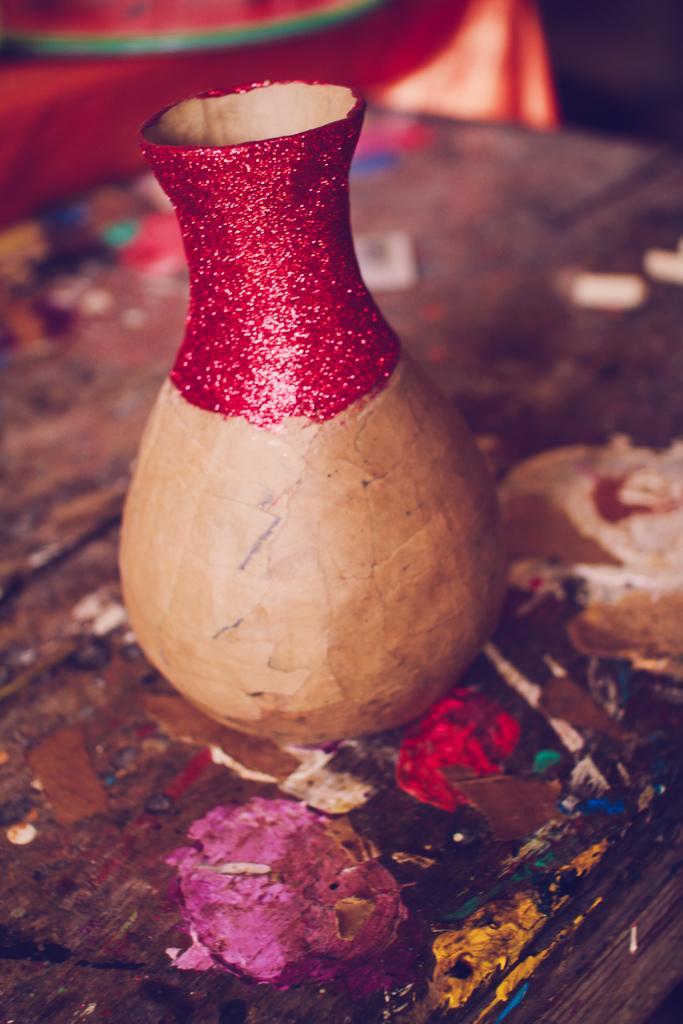Describe this image in one or two sentences. In this picture we can see a flower vase in the front, at the bottom there is a wooden surface, we can see a blurry background. 